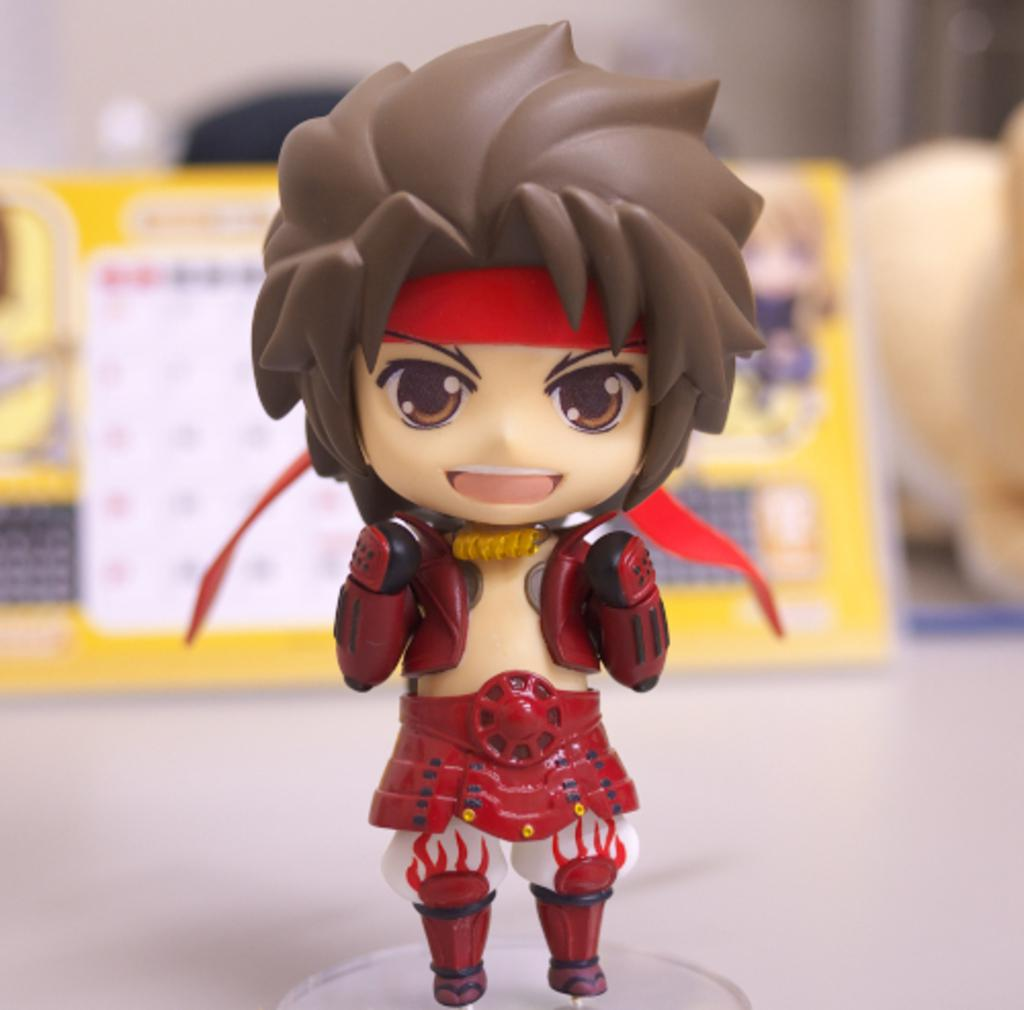What object can be seen in the image? There is a toy in the image. Can you describe the background of the image? The background of the image is blurry. What advice did your uncle give you before your attempt to sew with a needle in the image? There is no uncle, attempt, or needle present in the image. 